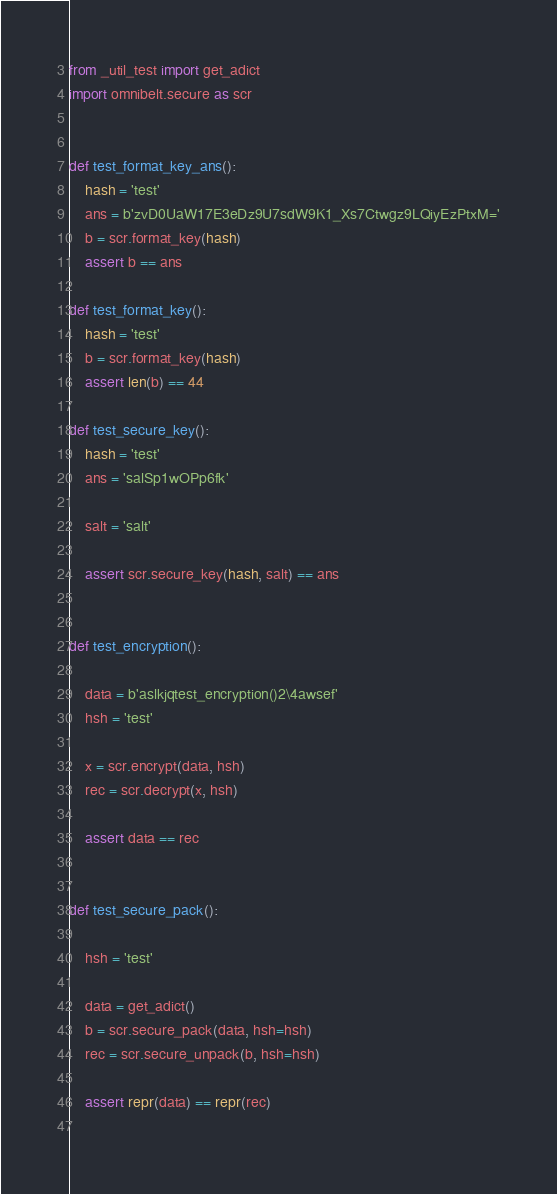<code> <loc_0><loc_0><loc_500><loc_500><_Python_>
from _util_test import get_adict
import omnibelt.secure as scr


def test_format_key_ans():
	hash = 'test'
	ans = b'zvD0UaW17E3eDz9U7sdW9K1_Xs7Ctwgz9LQiyEzPtxM='
	b = scr.format_key(hash)
	assert b == ans

def test_format_key():
	hash = 'test'
	b = scr.format_key(hash)
	assert len(b) == 44

def test_secure_key():
	hash = 'test'
	ans = 'salSp1wOPp6fk'
	
	salt = 'salt'

	assert scr.secure_key(hash, salt) == ans


def test_encryption():

	data = b'aslkjqtest_encryption()2\4awsef'
	hsh = 'test'
	
	x = scr.encrypt(data, hsh)
	rec = scr.decrypt(x, hsh)
	
	assert data == rec
	

def test_secure_pack():
	
	hsh = 'test'
	
	data = get_adict()
	b = scr.secure_pack(data, hsh=hsh)
	rec = scr.secure_unpack(b, hsh=hsh)
	
	assert repr(data) == repr(rec)
	
</code> 